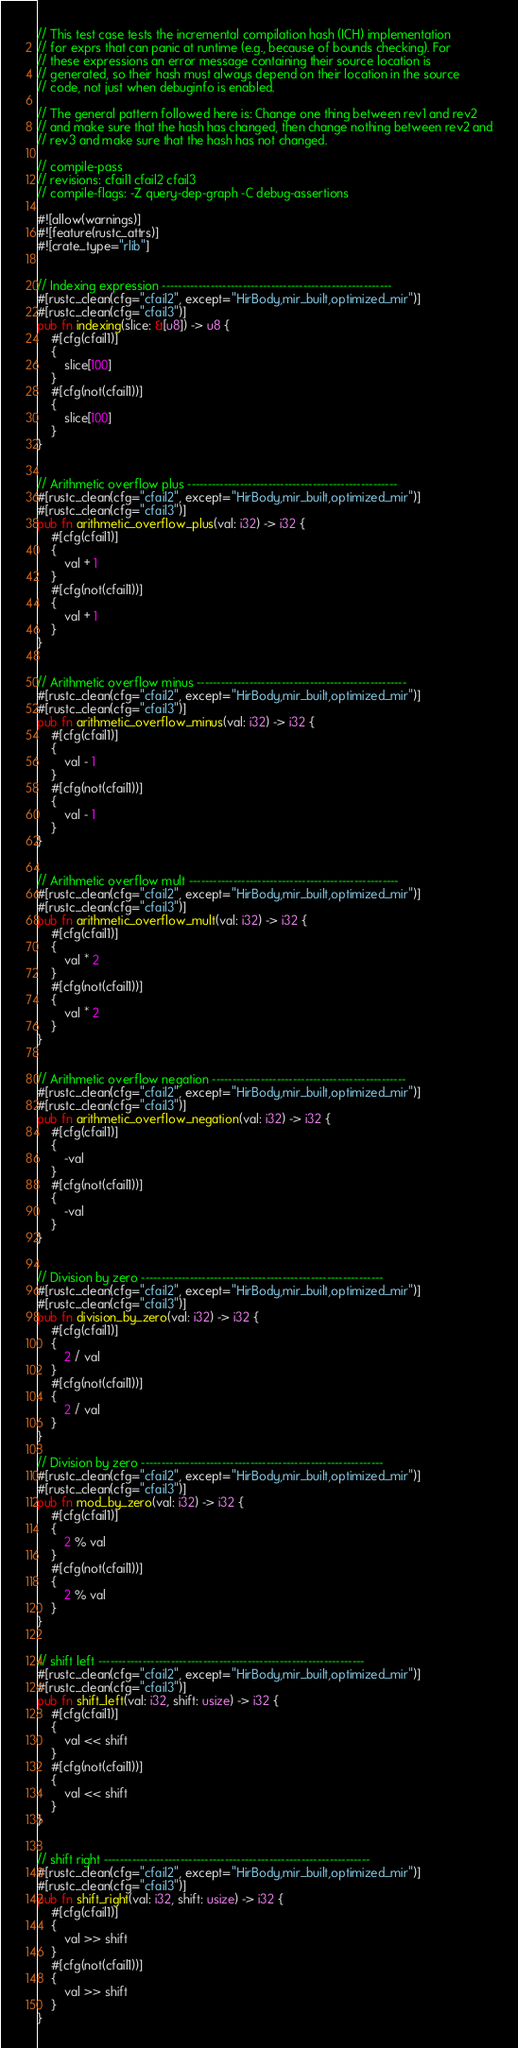Convert code to text. <code><loc_0><loc_0><loc_500><loc_500><_Rust_>// This test case tests the incremental compilation hash (ICH) implementation
// for exprs that can panic at runtime (e.g., because of bounds checking). For
// these expressions an error message containing their source location is
// generated, so their hash must always depend on their location in the source
// code, not just when debuginfo is enabled.

// The general pattern followed here is: Change one thing between rev1 and rev2
// and make sure that the hash has changed, then change nothing between rev2 and
// rev3 and make sure that the hash has not changed.

// compile-pass
// revisions: cfail1 cfail2 cfail3
// compile-flags: -Z query-dep-graph -C debug-assertions

#![allow(warnings)]
#![feature(rustc_attrs)]
#![crate_type="rlib"]


// Indexing expression ---------------------------------------------------------
#[rustc_clean(cfg="cfail2", except="HirBody,mir_built,optimized_mir")]
#[rustc_clean(cfg="cfail3")]
pub fn indexing(slice: &[u8]) -> u8 {
    #[cfg(cfail1)]
    {
        slice[100]
    }
    #[cfg(not(cfail1))]
    {
        slice[100]
    }
}


// Arithmetic overflow plus ----------------------------------------------------
#[rustc_clean(cfg="cfail2", except="HirBody,mir_built,optimized_mir")]
#[rustc_clean(cfg="cfail3")]
pub fn arithmetic_overflow_plus(val: i32) -> i32 {
    #[cfg(cfail1)]
    {
        val + 1
    }
    #[cfg(not(cfail1))]
    {
        val + 1
    }
}


// Arithmetic overflow minus ----------------------------------------------------
#[rustc_clean(cfg="cfail2", except="HirBody,mir_built,optimized_mir")]
#[rustc_clean(cfg="cfail3")]
pub fn arithmetic_overflow_minus(val: i32) -> i32 {
    #[cfg(cfail1)]
    {
        val - 1
    }
    #[cfg(not(cfail1))]
    {
        val - 1
    }
}


// Arithmetic overflow mult ----------------------------------------------------
#[rustc_clean(cfg="cfail2", except="HirBody,mir_built,optimized_mir")]
#[rustc_clean(cfg="cfail3")]
pub fn arithmetic_overflow_mult(val: i32) -> i32 {
    #[cfg(cfail1)]
    {
        val * 2
    }
    #[cfg(not(cfail1))]
    {
        val * 2
    }
}


// Arithmetic overflow negation ------------------------------------------------
#[rustc_clean(cfg="cfail2", except="HirBody,mir_built,optimized_mir")]
#[rustc_clean(cfg="cfail3")]
pub fn arithmetic_overflow_negation(val: i32) -> i32 {
    #[cfg(cfail1)]
    {
        -val
    }
    #[cfg(not(cfail1))]
    {
        -val
    }
}


// Division by zero ------------------------------------------------------------
#[rustc_clean(cfg="cfail2", except="HirBody,mir_built,optimized_mir")]
#[rustc_clean(cfg="cfail3")]
pub fn division_by_zero(val: i32) -> i32 {
    #[cfg(cfail1)]
    {
        2 / val
    }
    #[cfg(not(cfail1))]
    {
        2 / val
    }
}

// Division by zero ------------------------------------------------------------
#[rustc_clean(cfg="cfail2", except="HirBody,mir_built,optimized_mir")]
#[rustc_clean(cfg="cfail3")]
pub fn mod_by_zero(val: i32) -> i32 {
    #[cfg(cfail1)]
    {
        2 % val
    }
    #[cfg(not(cfail1))]
    {
        2 % val
    }
}


// shift left ------------------------------------------------------------------
#[rustc_clean(cfg="cfail2", except="HirBody,mir_built,optimized_mir")]
#[rustc_clean(cfg="cfail3")]
pub fn shift_left(val: i32, shift: usize) -> i32 {
    #[cfg(cfail1)]
    {
        val << shift
    }
    #[cfg(not(cfail1))]
    {
        val << shift
    }
}


// shift right ------------------------------------------------------------------
#[rustc_clean(cfg="cfail2", except="HirBody,mir_built,optimized_mir")]
#[rustc_clean(cfg="cfail3")]
pub fn shift_right(val: i32, shift: usize) -> i32 {
    #[cfg(cfail1)]
    {
        val >> shift
    }
    #[cfg(not(cfail1))]
    {
        val >> shift
    }
}
</code> 